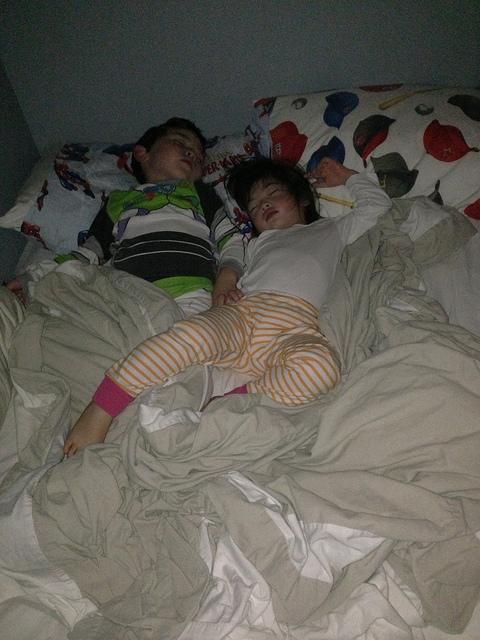Is one of the persons awake?
Short answer required. No. Are the children asleep?
Write a very short answer. Yes. Are the children awake?
Concise answer only. No. Are the children jumping on the bed?
Write a very short answer. No. Is the baby sleeping?
Keep it brief. Yes. Is the baby wearing pants?
Give a very brief answer. Yes. Is that a boy and a girl sleeping?
Quick response, please. Yes. What color is the photo?
Concise answer only. White. How many people can be seen?
Quick response, please. 2. What color is the blankets?
Short answer required. White. 